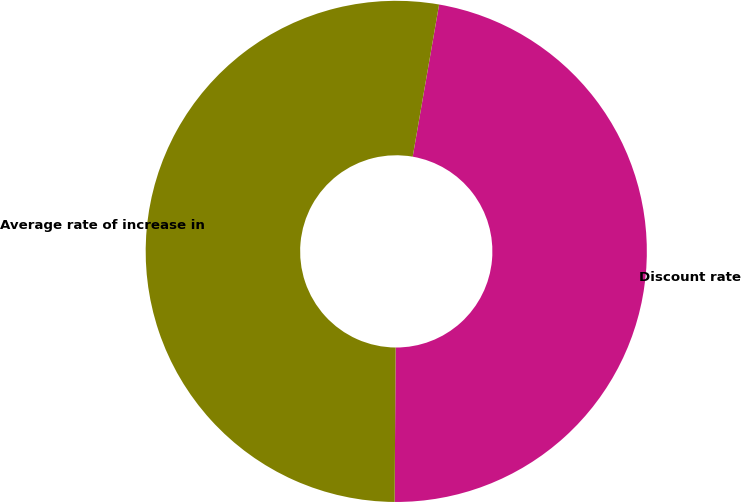Convert chart to OTSL. <chart><loc_0><loc_0><loc_500><loc_500><pie_chart><fcel>Discount rate<fcel>Average rate of increase in<nl><fcel>47.37%<fcel>52.63%<nl></chart> 